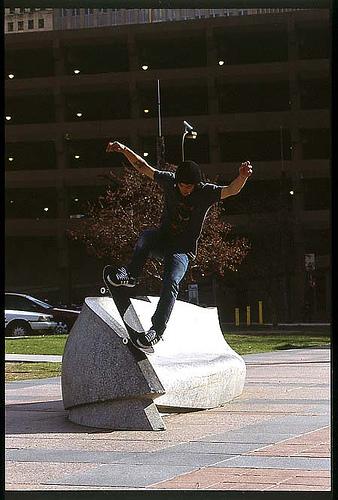What structure is in the background?
Keep it brief. Parking garage. Are the street lights on?
Write a very short answer. No. Is the skater doing a trick?
Be succinct. Yes. 